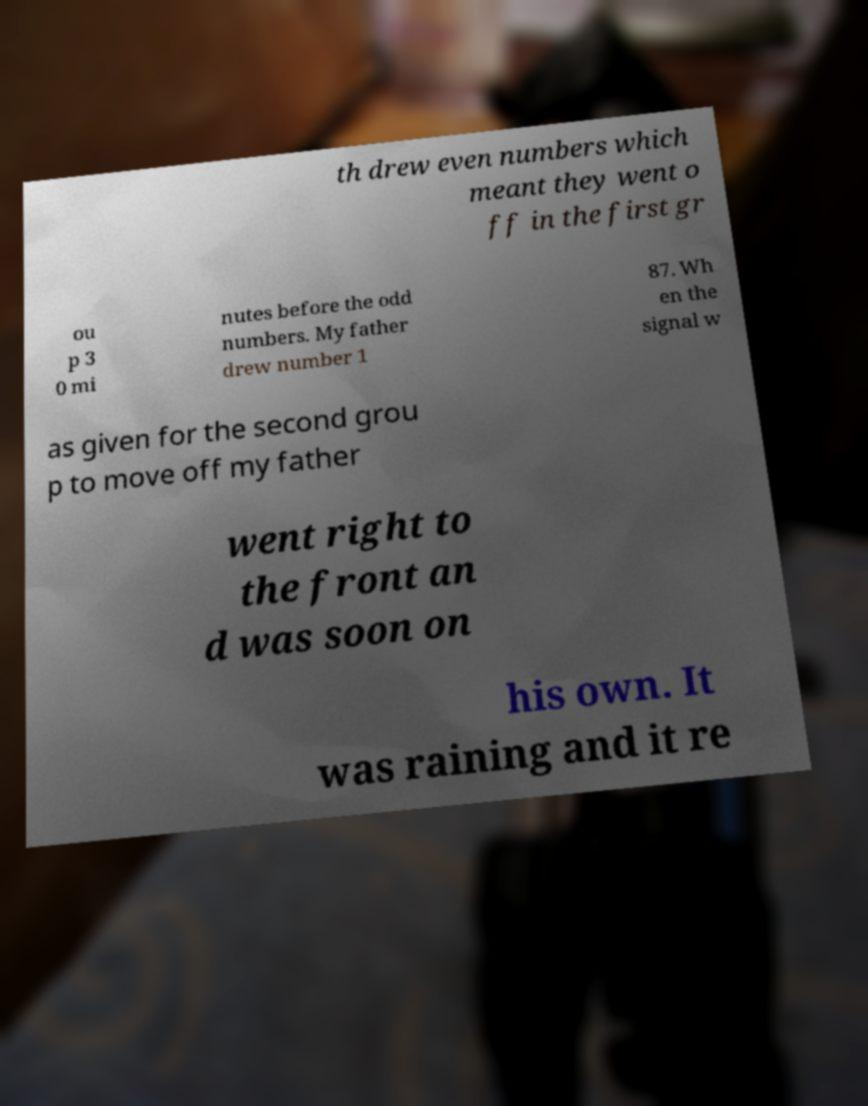I need the written content from this picture converted into text. Can you do that? th drew even numbers which meant they went o ff in the first gr ou p 3 0 mi nutes before the odd numbers. My father drew number 1 87. Wh en the signal w as given for the second grou p to move off my father went right to the front an d was soon on his own. It was raining and it re 